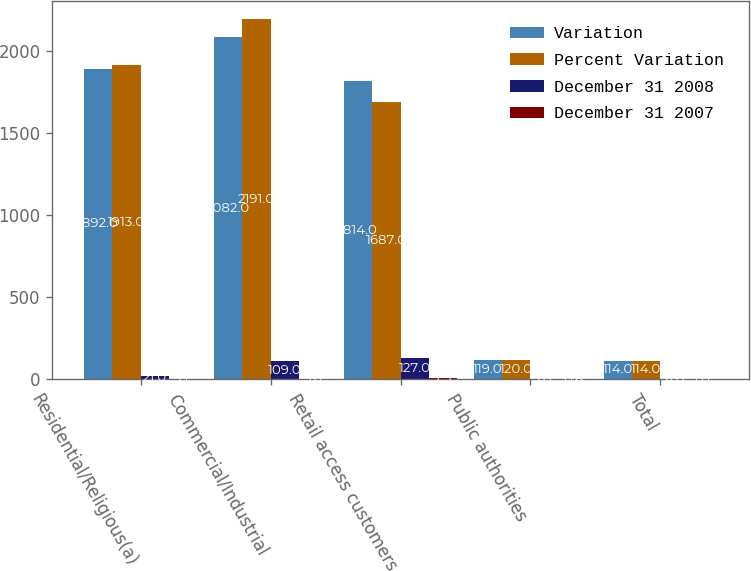<chart> <loc_0><loc_0><loc_500><loc_500><stacked_bar_chart><ecel><fcel>Residential/Religious(a)<fcel>Commercial/Industrial<fcel>Retail access customers<fcel>Public authorities<fcel>Total<nl><fcel>Variation<fcel>1892<fcel>2082<fcel>1814<fcel>119<fcel>114<nl><fcel>Percent Variation<fcel>1913<fcel>2191<fcel>1687<fcel>120<fcel>114<nl><fcel>December 31 2008<fcel>21<fcel>109<fcel>127<fcel>1<fcel>4<nl><fcel>December 31 2007<fcel>1.1<fcel>5<fcel>7.5<fcel>0.8<fcel>0.1<nl></chart> 